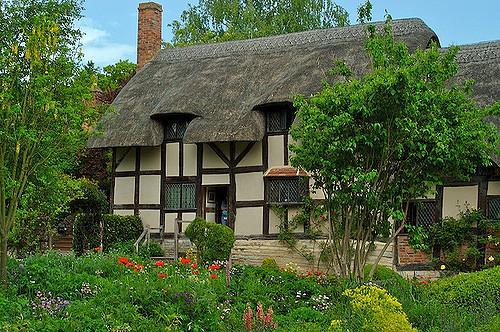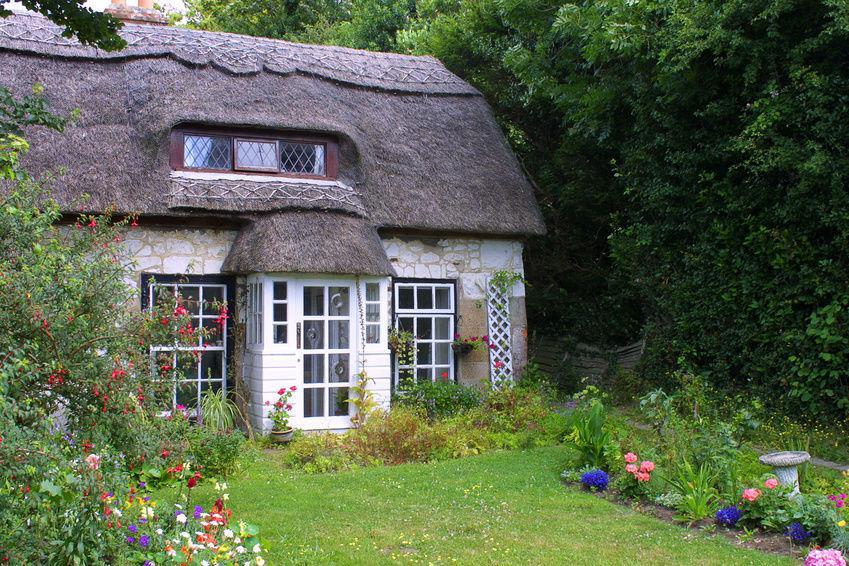The first image is the image on the left, the second image is the image on the right. For the images displayed, is the sentence "In at least one image there is a cream colored house with black stripes of wood that create a box look." factually correct? Answer yes or no. Yes. The first image is the image on the left, the second image is the image on the right. Considering the images on both sides, is "The left image shows a white house with bold dark lines on it forming geometric patterns, and a thatched roof with at least one notched cut-out for windows, and the right image shows a house with a thatched roof over the door and a roof over the house itself." valid? Answer yes or no. Yes. 